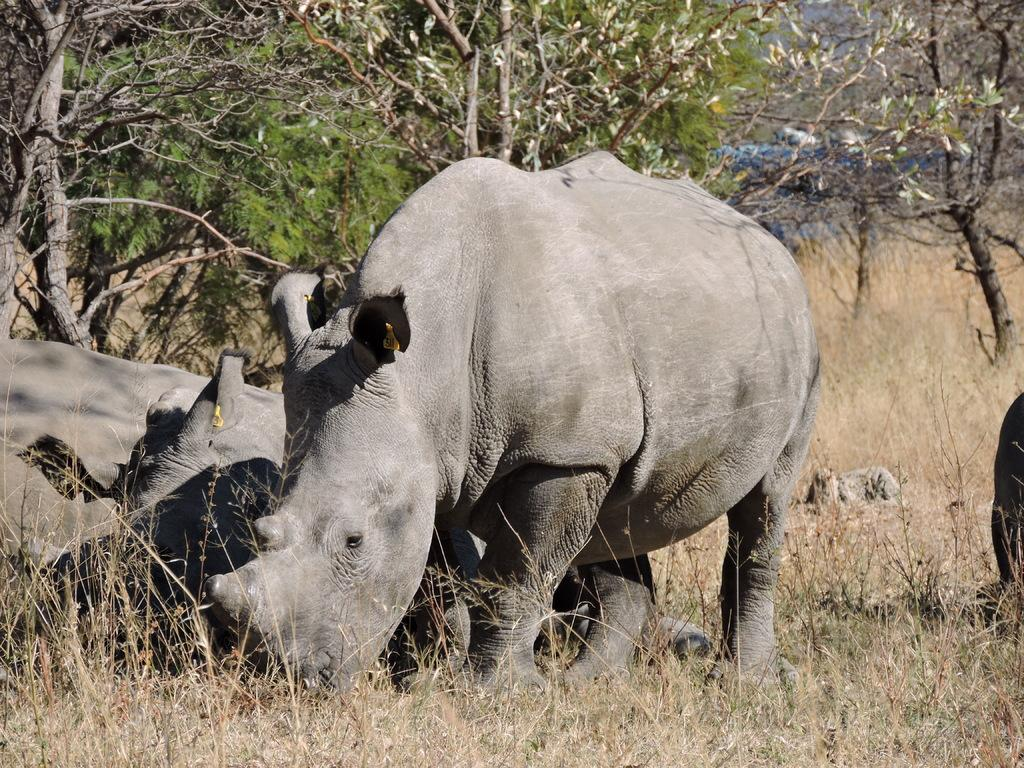What animal is on the ground in the image? There is a rhinoceros on the ground in the image. What type of vegetation can be seen in the image? There are plants and grass visible in the image. What can be seen in the background of the image? There is a group of trees in the image. What is visible above the ground in the image? The sky is visible in the image. What level of desire does the rhinoceros exhibit in the image? There is no indication of the rhinoceros's level of desire in the image. 